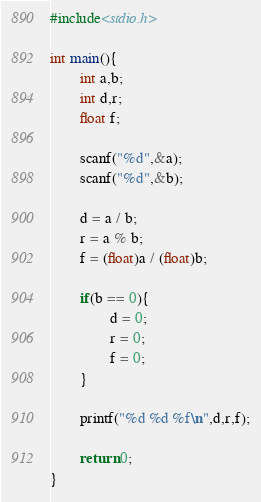<code> <loc_0><loc_0><loc_500><loc_500><_C_>#include<stdio.h>

int main(){
        int a,b;
        int d,r;
        float f;

        scanf("%d",&a);
        scanf("%d",&b);

        d = a / b;
        r = a % b;
        f = (float)a / (float)b;

        if(b == 0){
                d = 0;
                r = 0;
                f = 0;
        }

        printf("%d %d %f\n",d,r,f);

        return 0;
}</code> 